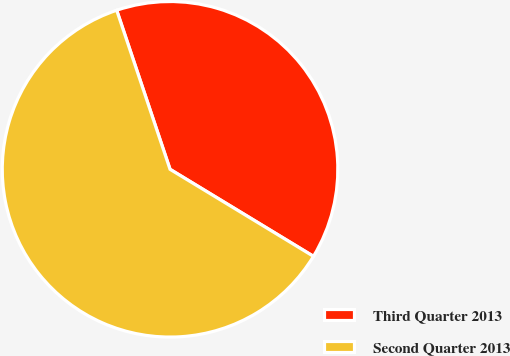Convert chart to OTSL. <chart><loc_0><loc_0><loc_500><loc_500><pie_chart><fcel>Third Quarter 2013<fcel>Second Quarter 2013<nl><fcel>38.83%<fcel>61.17%<nl></chart> 